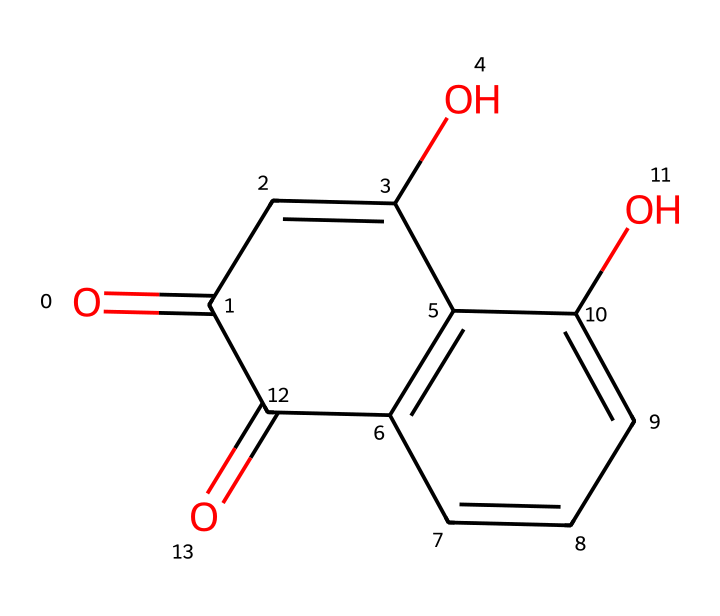What is the molecular formula of the dye represented by this SMILES? To determine the molecular formula, we first analyze the SMILES. The structure contains 15 carbon atoms (C), 10 hydrogen atoms (H), and 5 oxygen atoms (O). Therefore, we can combine these counts into the molecular formula, resulting in C15H10O5.
Answer: C15H10O5 How many rings are present in the chemical structure? By examining the SMILES representation, we identify two ring structures based on the notation (indicated by the numbers). Therefore, there are two rings present.
Answer: 2 Which functional groups are found in this molecule? The SMILES shows the presence of carbonyl (C=O) and hydroxyl (–OH) groups in the structure. We identify these functional groups through the presence of the carbonyl (C=O) at the ends of the compound and hydroxyl groups on the rings.
Answer: carbonyl and hydroxyl What type of compounds are typically formed through structures like this? Structures like this one, which include several aromatic rings and functional groups consistent with flavonoids, indicate this chemical is a type of dye. This reasoning comes from knowing that such compounds can produce color when interacting with fabrics or materials.
Answer: dye What property might make this dye useful for coloring textiles? The presence of multiple functional groups and aromatic rings usually indicates that this dye can form strong interactions with fabric fibers, resulting in good color retention and vibrancy. This is inferred from the structural features of the molecule.
Answer: good color retention How does the presence of hydroxyl groups affect the solubility of this dye? Hydroxyl groups are polar and can form hydrogen bonds with water molecules, increasing the solubility of the dye in aqueous solutions. This effect is a consequence of the polar nature of hydroxyl groups in organic compounds.
Answer: increases solubility 